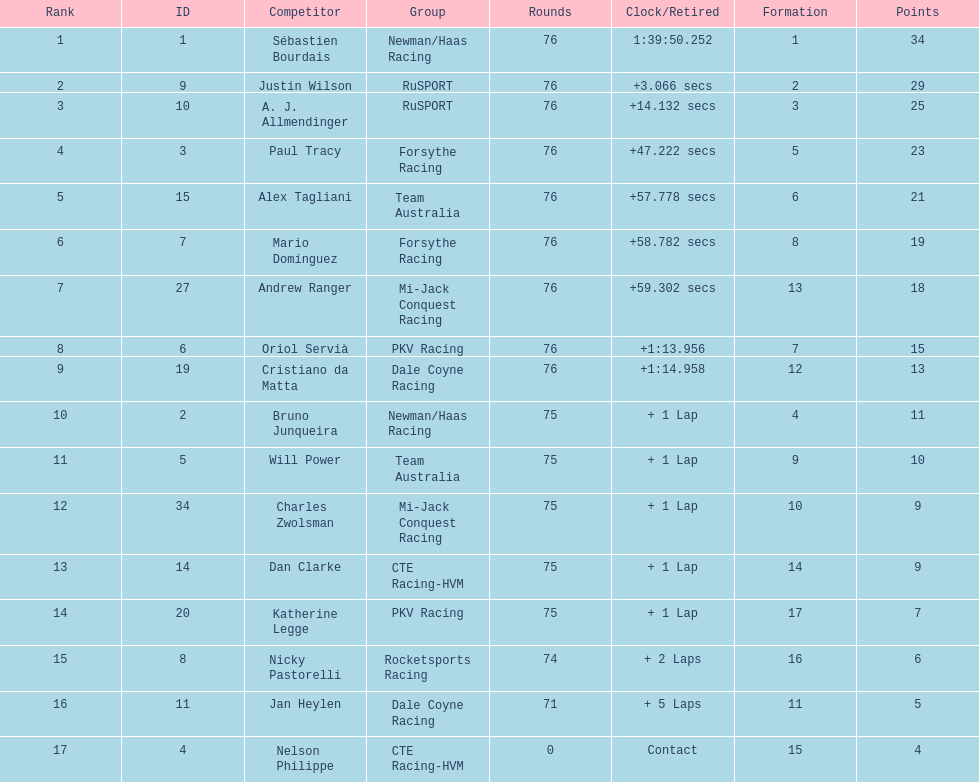Would you be able to parse every entry in this table? {'header': ['Rank', 'ID', 'Competitor', 'Group', 'Rounds', 'Clock/Retired', 'Formation', 'Points'], 'rows': [['1', '1', 'Sébastien Bourdais', 'Newman/Haas Racing', '76', '1:39:50.252', '1', '34'], ['2', '9', 'Justin Wilson', 'RuSPORT', '76', '+3.066 secs', '2', '29'], ['3', '10', 'A. J. Allmendinger', 'RuSPORT', '76', '+14.132 secs', '3', '25'], ['4', '3', 'Paul Tracy', 'Forsythe Racing', '76', '+47.222 secs', '5', '23'], ['5', '15', 'Alex Tagliani', 'Team Australia', '76', '+57.778 secs', '6', '21'], ['6', '7', 'Mario Domínguez', 'Forsythe Racing', '76', '+58.782 secs', '8', '19'], ['7', '27', 'Andrew Ranger', 'Mi-Jack Conquest Racing', '76', '+59.302 secs', '13', '18'], ['8', '6', 'Oriol Servià', 'PKV Racing', '76', '+1:13.956', '7', '15'], ['9', '19', 'Cristiano da Matta', 'Dale Coyne Racing', '76', '+1:14.958', '12', '13'], ['10', '2', 'Bruno Junqueira', 'Newman/Haas Racing', '75', '+ 1 Lap', '4', '11'], ['11', '5', 'Will Power', 'Team Australia', '75', '+ 1 Lap', '9', '10'], ['12', '34', 'Charles Zwolsman', 'Mi-Jack Conquest Racing', '75', '+ 1 Lap', '10', '9'], ['13', '14', 'Dan Clarke', 'CTE Racing-HVM', '75', '+ 1 Lap', '14', '9'], ['14', '20', 'Katherine Legge', 'PKV Racing', '75', '+ 1 Lap', '17', '7'], ['15', '8', 'Nicky Pastorelli', 'Rocketsports Racing', '74', '+ 2 Laps', '16', '6'], ['16', '11', 'Jan Heylen', 'Dale Coyne Racing', '71', '+ 5 Laps', '11', '5'], ['17', '4', 'Nelson Philippe', 'CTE Racing-HVM', '0', 'Contact', '15', '4']]} Which canadian driver finished first: alex tagliani or paul tracy? Paul Tracy. 